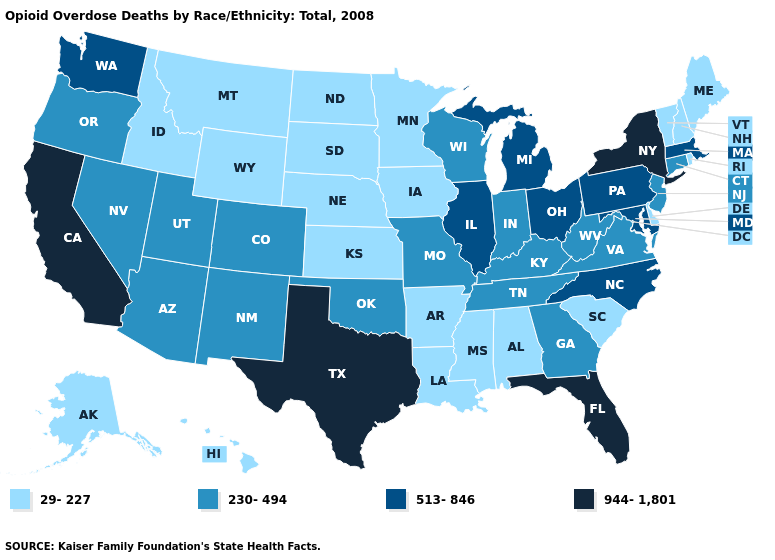Does Kentucky have the same value as North Dakota?
Be succinct. No. What is the value of New York?
Be succinct. 944-1,801. Does Georgia have the same value as North Carolina?
Concise answer only. No. What is the lowest value in states that border Washington?
Short answer required. 29-227. What is the value of Alabama?
Keep it brief. 29-227. What is the value of Maine?
Quick response, please. 29-227. Does California have the highest value in the USA?
Answer briefly. Yes. Name the states that have a value in the range 944-1,801?
Answer briefly. California, Florida, New York, Texas. Does the map have missing data?
Short answer required. No. Among the states that border Idaho , which have the highest value?
Give a very brief answer. Washington. What is the highest value in the Northeast ?
Be succinct. 944-1,801. Does Connecticut have a higher value than Colorado?
Quick response, please. No. Does Kansas have the lowest value in the USA?
Concise answer only. Yes. Name the states that have a value in the range 230-494?
Write a very short answer. Arizona, Colorado, Connecticut, Georgia, Indiana, Kentucky, Missouri, Nevada, New Jersey, New Mexico, Oklahoma, Oregon, Tennessee, Utah, Virginia, West Virginia, Wisconsin. What is the value of Massachusetts?
Quick response, please. 513-846. 